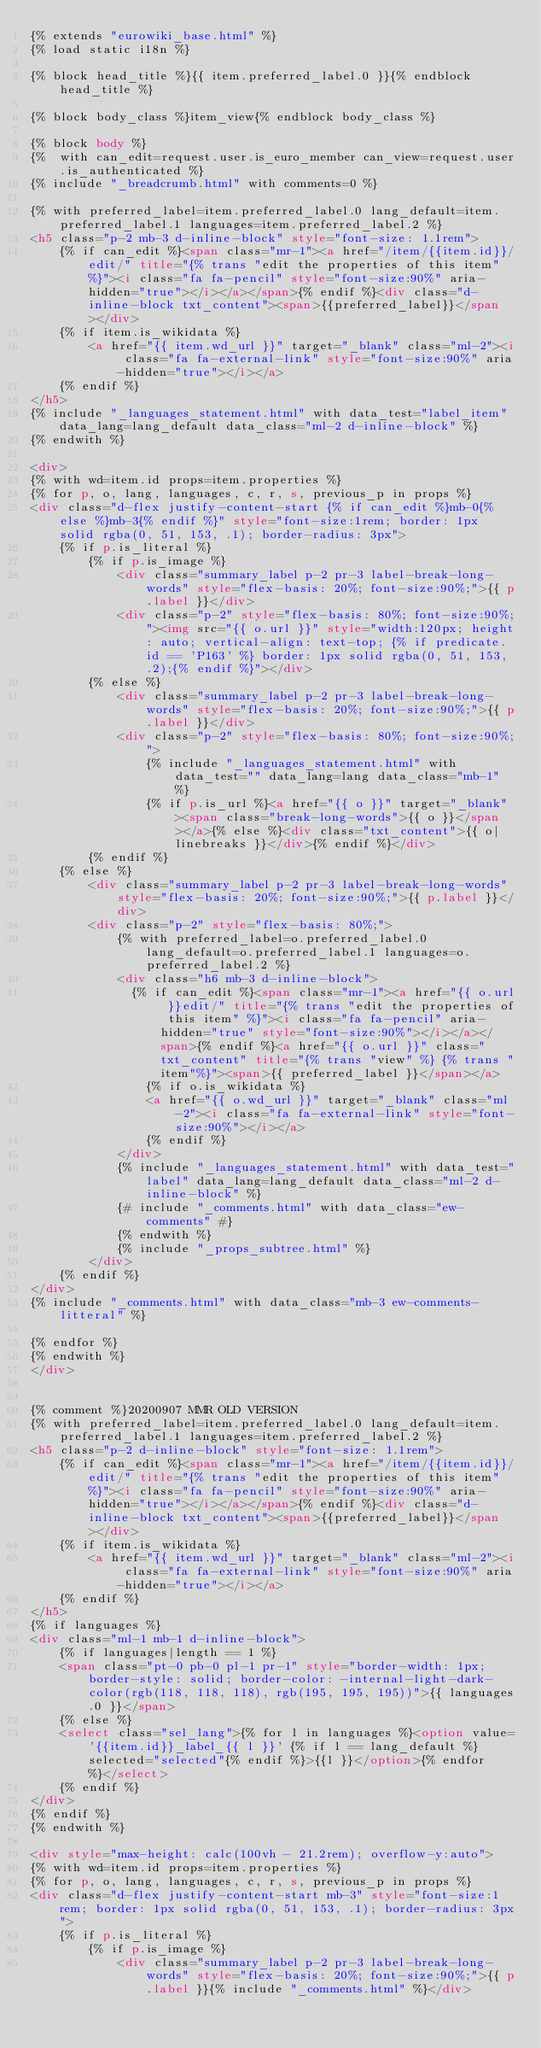<code> <loc_0><loc_0><loc_500><loc_500><_HTML_>{% extends "eurowiki_base.html" %}
{% load static i18n %}

{% block head_title %}{{ item.preferred_label.0 }}{% endblock head_title %}

{% block body_class %}item_view{% endblock body_class %}

{% block body %}
{%  with can_edit=request.user.is_euro_member can_view=request.user.is_authenticated %}
{% include "_breadcrumb.html" with comments=0 %}

{% with preferred_label=item.preferred_label.0 lang_default=item.preferred_label.1 languages=item.preferred_label.2 %}
<h5 class="p-2 mb-3 d-inline-block" style="font-size: 1.1rem">
    {% if can_edit %}<span class="mr-1"><a href="/item/{{item.id}}/edit/" title="{% trans "edit the properties of this item" %}"><i class="fa fa-pencil" style="font-size:90%" aria-hidden="true"></i></a></span>{% endif %}<div class="d-inline-block txt_content"><span>{{preferred_label}}</span></div>
    {% if item.is_wikidata %}
        <a href="{{ item.wd_url }}" target="_blank" class="ml-2"><i class="fa fa-external-link" style="font-size:90%" aria-hidden="true"></i></a>
    {% endif %}
</h5>
{% include "_languages_statement.html" with data_test="label_item" data_lang=lang_default data_class="ml-2 d-inline-block" %} 
{% endwith %}

<div>
{% with wd=item.id props=item.properties %}
{% for p, o, lang, languages, c, r, s, previous_p in props %}
<div class="d-flex justify-content-start {% if can_edit %}mb-0{% else %}mb-3{% endif %}" style="font-size:1rem; border: 1px solid rgba(0, 51, 153, .1); border-radius: 3px">
    {% if p.is_literal %}
        {% if p.is_image %}
            <div class="summary_label p-2 pr-3 label-break-long-words" style="flex-basis: 20%; font-size:90%;">{{ p.label }}</div>
            <div class="p-2" style="flex-basis: 80%; font-size:90%;"><img src="{{ o.url }}" style="width:120px; height: auto; vertical-align: text-top; {% if predicate.id == 'P163' %} border: 1px solid rgba(0, 51, 153, .2);{% endif %}"></div>
        {% else %}
            <div class="summary_label p-2 pr-3 label-break-long-words" style="flex-basis: 20%; font-size:90%;">{{ p.label }}</div>
            <div class="p-2" style="flex-basis: 80%; font-size:90%;">
                {% include "_languages_statement.html" with data_test="" data_lang=lang data_class="mb-1" %}   
                {% if p.is_url %}<a href="{{ o }}" target="_blank"><span class="break-long-words">{{ o }}</span></a>{% else %}<div class="txt_content">{{ o|linebreaks }}</div>{% endif %}</div>
        {% endif %}
    {% else %}
        <div class="summary_label p-2 pr-3 label-break-long-words" style="flex-basis: 20%; font-size:90%;">{{ p.label }}</div>
        <div class="p-2" style="flex-basis: 80%;">
            {% with preferred_label=o.preferred_label.0 lang_default=o.preferred_label.1 languages=o.preferred_label.2 %}
            <div class="h6 mb-3 d-inline-block">
            	{% if can_edit %}<span class="mr-1"><a href="{{ o.url }}edit/" title="{% trans "edit the properties of this item" %}"><i class="fa fa-pencil" aria-hidden="true" style="font-size:90%"></i></a></span>{% endif %}<a href="{{ o.url }}" class="txt_content" title="{% trans "view" %} {% trans "item"%}"><span>{{ preferred_label }}</span></a>
                {% if o.is_wikidata %}
                <a href="{{ o.wd_url }}" target="_blank" class="ml-2"><i class="fa fa-external-link" style="font-size:90%"></i></a>
                {% endif %}
            </div>
            {% include "_languages_statement.html" with data_test="label" data_lang=lang_default data_class="ml-2 d-inline-block" %}   
            {# include "_comments.html" with data_class="ew-comments" #}
            {% endwith %}
            {% include "_props_subtree.html" %}
        </div>
    {% endif %}
</div>
{% include "_comments.html" with data_class="mb-3 ew-comments-litteral" %}

{% endfor %}
{% endwith %}
</div>


{% comment %}20200907 MMR OLD VERSION
{% with preferred_label=item.preferred_label.0 lang_default=item.preferred_label.1 languages=item.preferred_label.2 %}
<h5 class="p-2 d-inline-block" style="font-size: 1.1rem">
    {% if can_edit %}<span class="mr-1"><a href="/item/{{item.id}}/edit/" title="{% trans "edit the properties of this item" %}"><i class="fa fa-pencil" style="font-size:90%" aria-hidden="true"></i></a></span>{% endif %}<div class="d-inline-block txt_content"><span>{{preferred_label}}</span></div>
    {% if item.is_wikidata %}
        <a href="{{ item.wd_url }}" target="_blank" class="ml-2"><i class="fa fa-external-link" style="font-size:90%" aria-hidden="true"></i></a>
    {% endif %}
</h5>
{% if languages %}
<div class="ml-1 mb-1 d-inline-block">
    {% if languages|length == 1 %}
    <span class="pt-0 pb-0 pl-1 pr-1" style="border-width: 1px; border-style: solid; border-color: -internal-light-dark-color(rgb(118, 118, 118), rgb(195, 195, 195))">{{ languages.0 }}</span>
    {% else %}
    <select class="sel_lang">{% for l in languages %}<option value='{{item.id}}_label_{{ l }}' {% if l == lang_default %}selected="selected"{% endif %}>{{l }}</option>{% endfor %}</select>
    {% endif %}
</div>
{% endif %}
{% endwith %}

<div style="max-height: calc(100vh - 21.2rem); overflow-y:auto">
{% with wd=item.id props=item.properties %}
{% for p, o, lang, languages, c, r, s, previous_p in props %}
<div class="d-flex justify-content-start mb-3" style="font-size:1rem; border: 1px solid rgba(0, 51, 153, .1); border-radius: 3px">
    {% if p.is_literal %}
        {% if p.is_image %}
            <div class="summary_label p-2 pr-3 label-break-long-words" style="flex-basis: 20%; font-size:90%;">{{ p.label }}{% include "_comments.html" %}</div></code> 